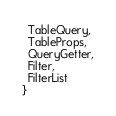<code> <loc_0><loc_0><loc_500><loc_500><_TypeScript_>  TableQuery,
  TableProps,
  QueryGetter,
  Filter,
  FilterList
}


</code> 